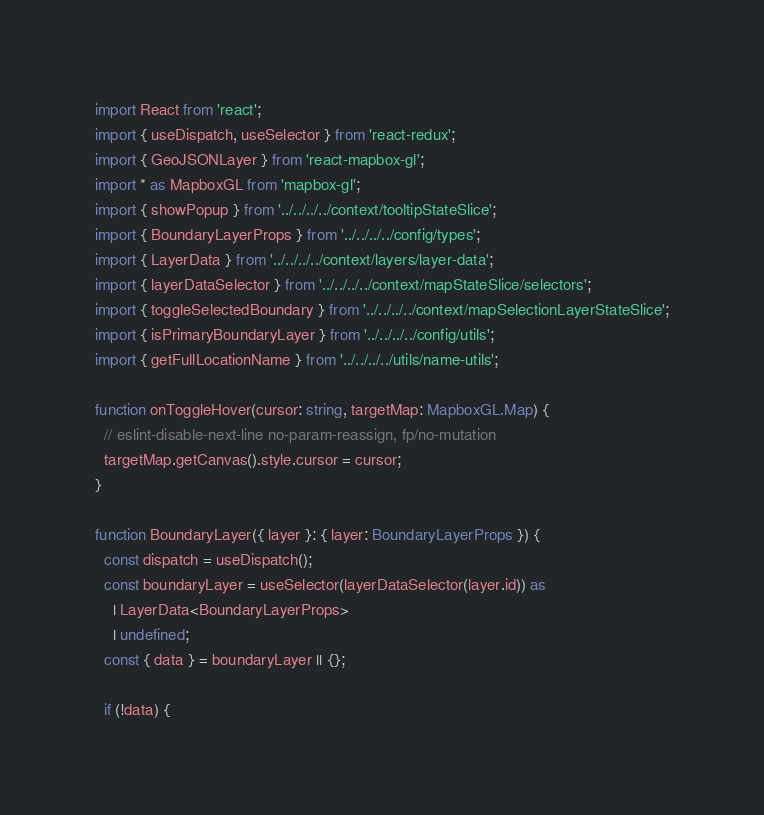Convert code to text. <code><loc_0><loc_0><loc_500><loc_500><_TypeScript_>import React from 'react';
import { useDispatch, useSelector } from 'react-redux';
import { GeoJSONLayer } from 'react-mapbox-gl';
import * as MapboxGL from 'mapbox-gl';
import { showPopup } from '../../../../context/tooltipStateSlice';
import { BoundaryLayerProps } from '../../../../config/types';
import { LayerData } from '../../../../context/layers/layer-data';
import { layerDataSelector } from '../../../../context/mapStateSlice/selectors';
import { toggleSelectedBoundary } from '../../../../context/mapSelectionLayerStateSlice';
import { isPrimaryBoundaryLayer } from '../../../../config/utils';
import { getFullLocationName } from '../../../../utils/name-utils';

function onToggleHover(cursor: string, targetMap: MapboxGL.Map) {
  // eslint-disable-next-line no-param-reassign, fp/no-mutation
  targetMap.getCanvas().style.cursor = cursor;
}

function BoundaryLayer({ layer }: { layer: BoundaryLayerProps }) {
  const dispatch = useDispatch();
  const boundaryLayer = useSelector(layerDataSelector(layer.id)) as
    | LayerData<BoundaryLayerProps>
    | undefined;
  const { data } = boundaryLayer || {};

  if (!data) {</code> 